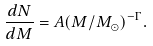<formula> <loc_0><loc_0><loc_500><loc_500>\frac { d N } { d M } = A ( M / M _ { \odot } ) ^ { - \Gamma } .</formula> 